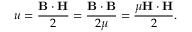Convert formula to latex. <formula><loc_0><loc_0><loc_500><loc_500>u = { \frac { B \cdot H } { 2 } } = { \frac { B \cdot B } { 2 \mu } } = { \frac { \mu H \cdot H } { 2 } } .</formula> 